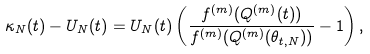Convert formula to latex. <formula><loc_0><loc_0><loc_500><loc_500>\kappa _ { N } ( t ) - U _ { N } ( t ) = U _ { N } ( t ) \left ( \frac { f ^ { ( m ) } ( Q ^ { ( m ) } ( t ) ) } { f ^ { ( m ) } ( Q ^ { ( m ) } ( \theta _ { t , N } ) ) } - 1 \right ) ,</formula> 